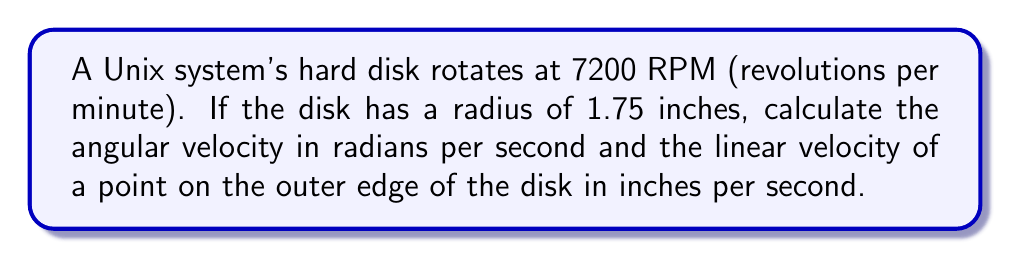Could you help me with this problem? To solve this problem, we'll follow these steps:

1) First, let's convert RPM to radians per second (rad/s):
   $$ \omega = \frac{7200 \text{ rev}}{1 \text{ min}} \cdot \frac{2\pi \text{ rad}}{1 \text{ rev}} \cdot \frac{1 \text{ min}}{60 \text{ s}} $$
   $$ \omega = 7200 \cdot 2\pi \cdot \frac{1}{60} = 240\pi \approx 753.98 \text{ rad/s} $$

2) Now that we have the angular velocity, we can calculate the linear velocity using the formula:
   $$ v = r\omega $$
   where $v$ is the linear velocity, $r$ is the radius, and $\omega$ is the angular velocity.

3) Plugging in our values:
   $$ v = 1.75 \text{ inches} \cdot 240\pi \text{ rad/s} $$
   $$ v = 420\pi \text{ inches/s} \approx 1319.47 \text{ inches/s} $$

This problem demonstrates the relationship between angular and linear velocity, which is crucial in disk storage systems. The high rotational speed allows for quick data access, a key factor in system performance that Unix pioneers like Dennis Ritchie and Ken Thompson would have been concerned with in their work on operating systems and file systems.
Answer: $\omega \approx 753.98 \text{ rad/s}$, $v \approx 1319.47 \text{ in/s}$ 